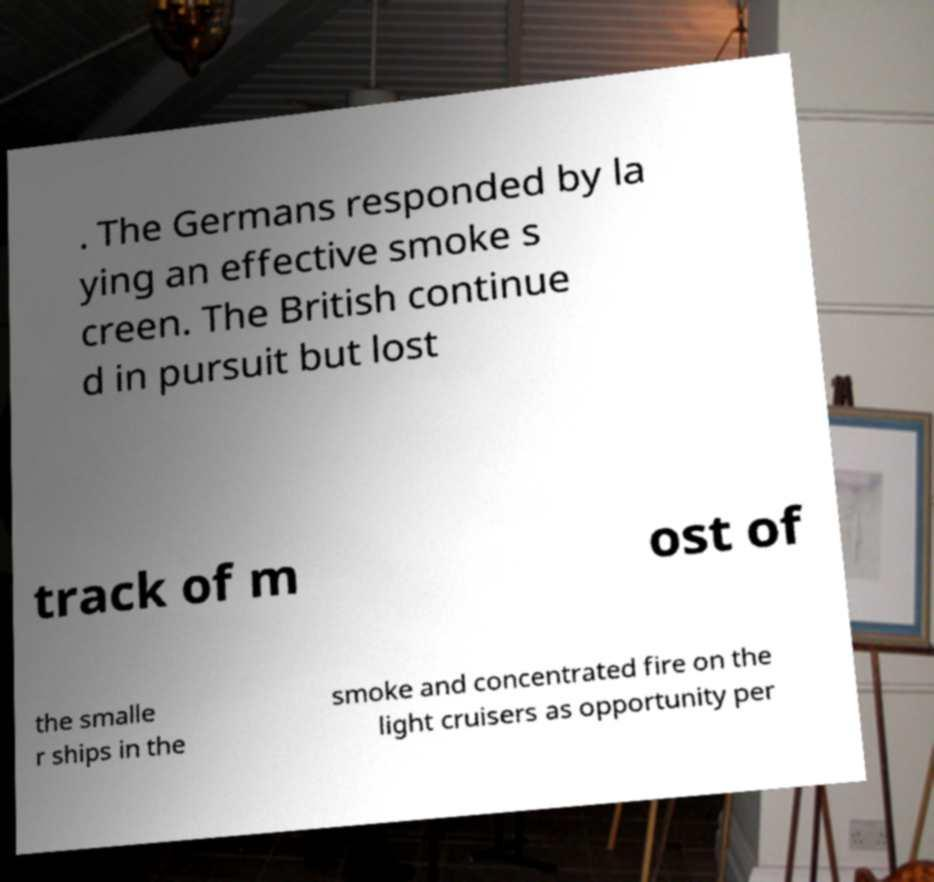I need the written content from this picture converted into text. Can you do that? . The Germans responded by la ying an effective smoke s creen. The British continue d in pursuit but lost track of m ost of the smalle r ships in the smoke and concentrated fire on the light cruisers as opportunity per 